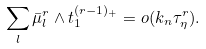Convert formula to latex. <formula><loc_0><loc_0><loc_500><loc_500>\sum _ { l } \bar { \mu } _ { l } ^ { r } \wedge t _ { 1 } ^ { ( r - 1 ) _ { + } } = o ( k _ { n } \tau _ { \eta } ^ { r } ) .</formula> 